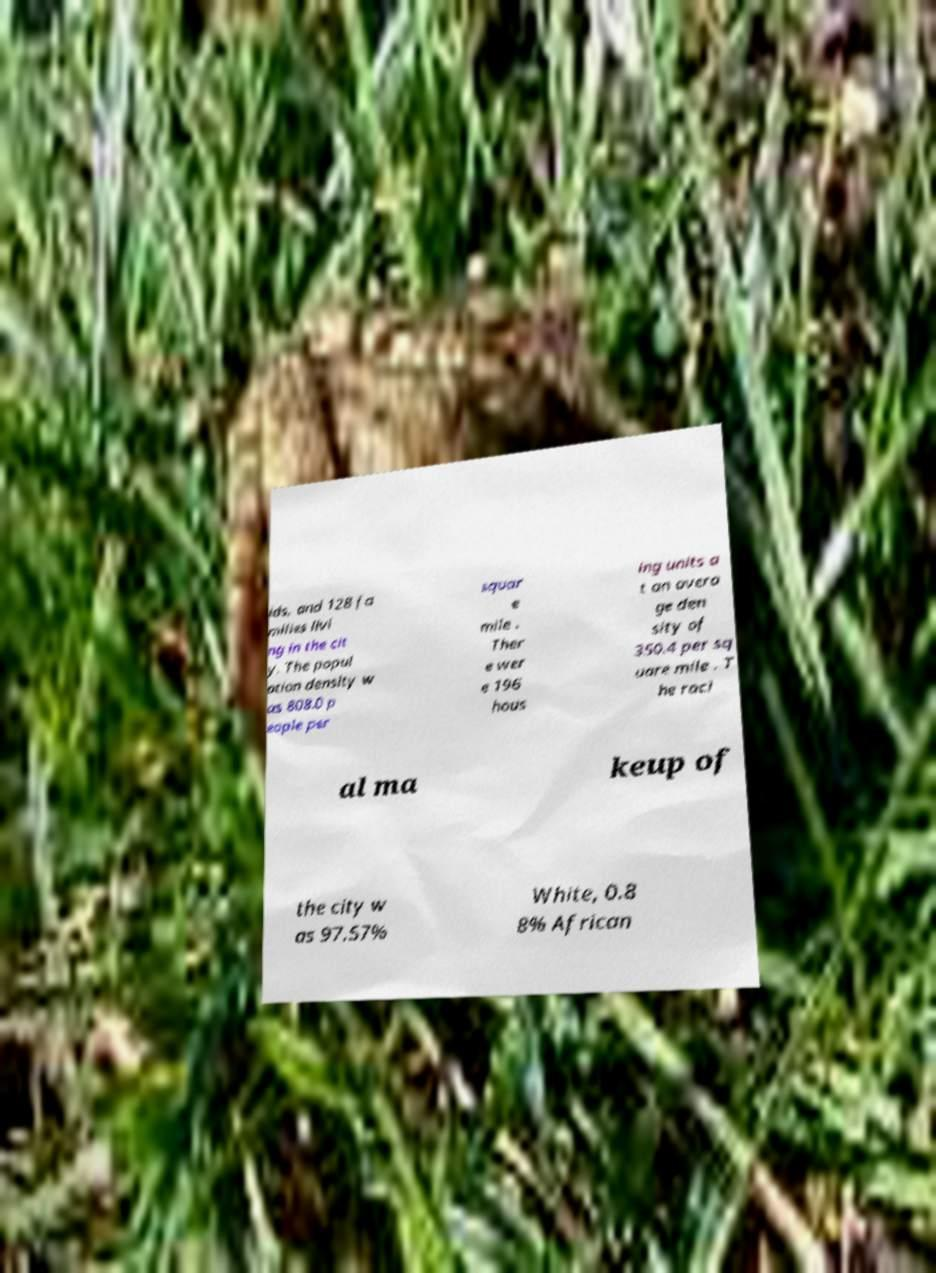There's text embedded in this image that I need extracted. Can you transcribe it verbatim? lds, and 128 fa milies livi ng in the cit y. The popul ation density w as 808.0 p eople per squar e mile . Ther e wer e 196 hous ing units a t an avera ge den sity of 350.4 per sq uare mile . T he raci al ma keup of the city w as 97.57% White, 0.8 8% African 